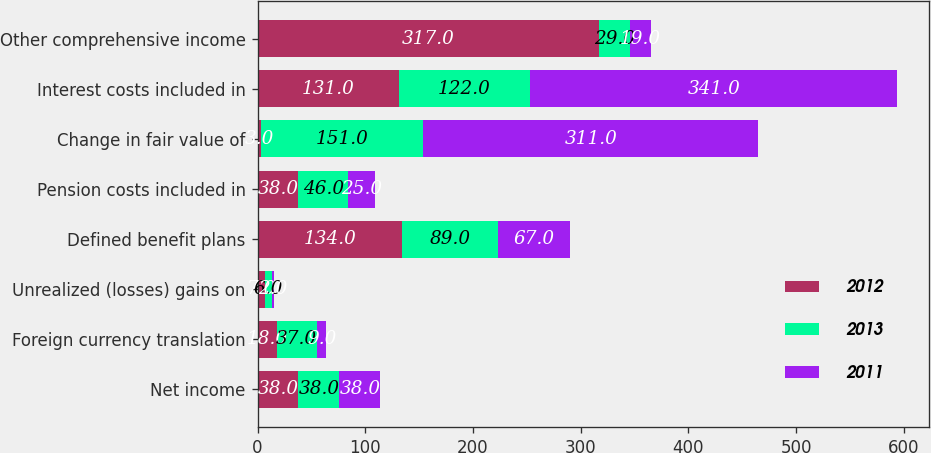Convert chart to OTSL. <chart><loc_0><loc_0><loc_500><loc_500><stacked_bar_chart><ecel><fcel>Net income<fcel>Foreign currency translation<fcel>Unrealized (losses) gains on<fcel>Defined benefit plans<fcel>Pension costs included in<fcel>Change in fair value of<fcel>Interest costs included in<fcel>Other comprehensive income<nl><fcel>2012<fcel>38<fcel>18<fcel>7<fcel>134<fcel>38<fcel>3<fcel>131<fcel>317<nl><fcel>2013<fcel>38<fcel>37<fcel>6<fcel>89<fcel>46<fcel>151<fcel>122<fcel>29<nl><fcel>2011<fcel>38<fcel>9<fcel>2<fcel>67<fcel>25<fcel>311<fcel>341<fcel>19<nl></chart> 